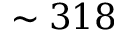<formula> <loc_0><loc_0><loc_500><loc_500>\sim 3 1 8</formula> 